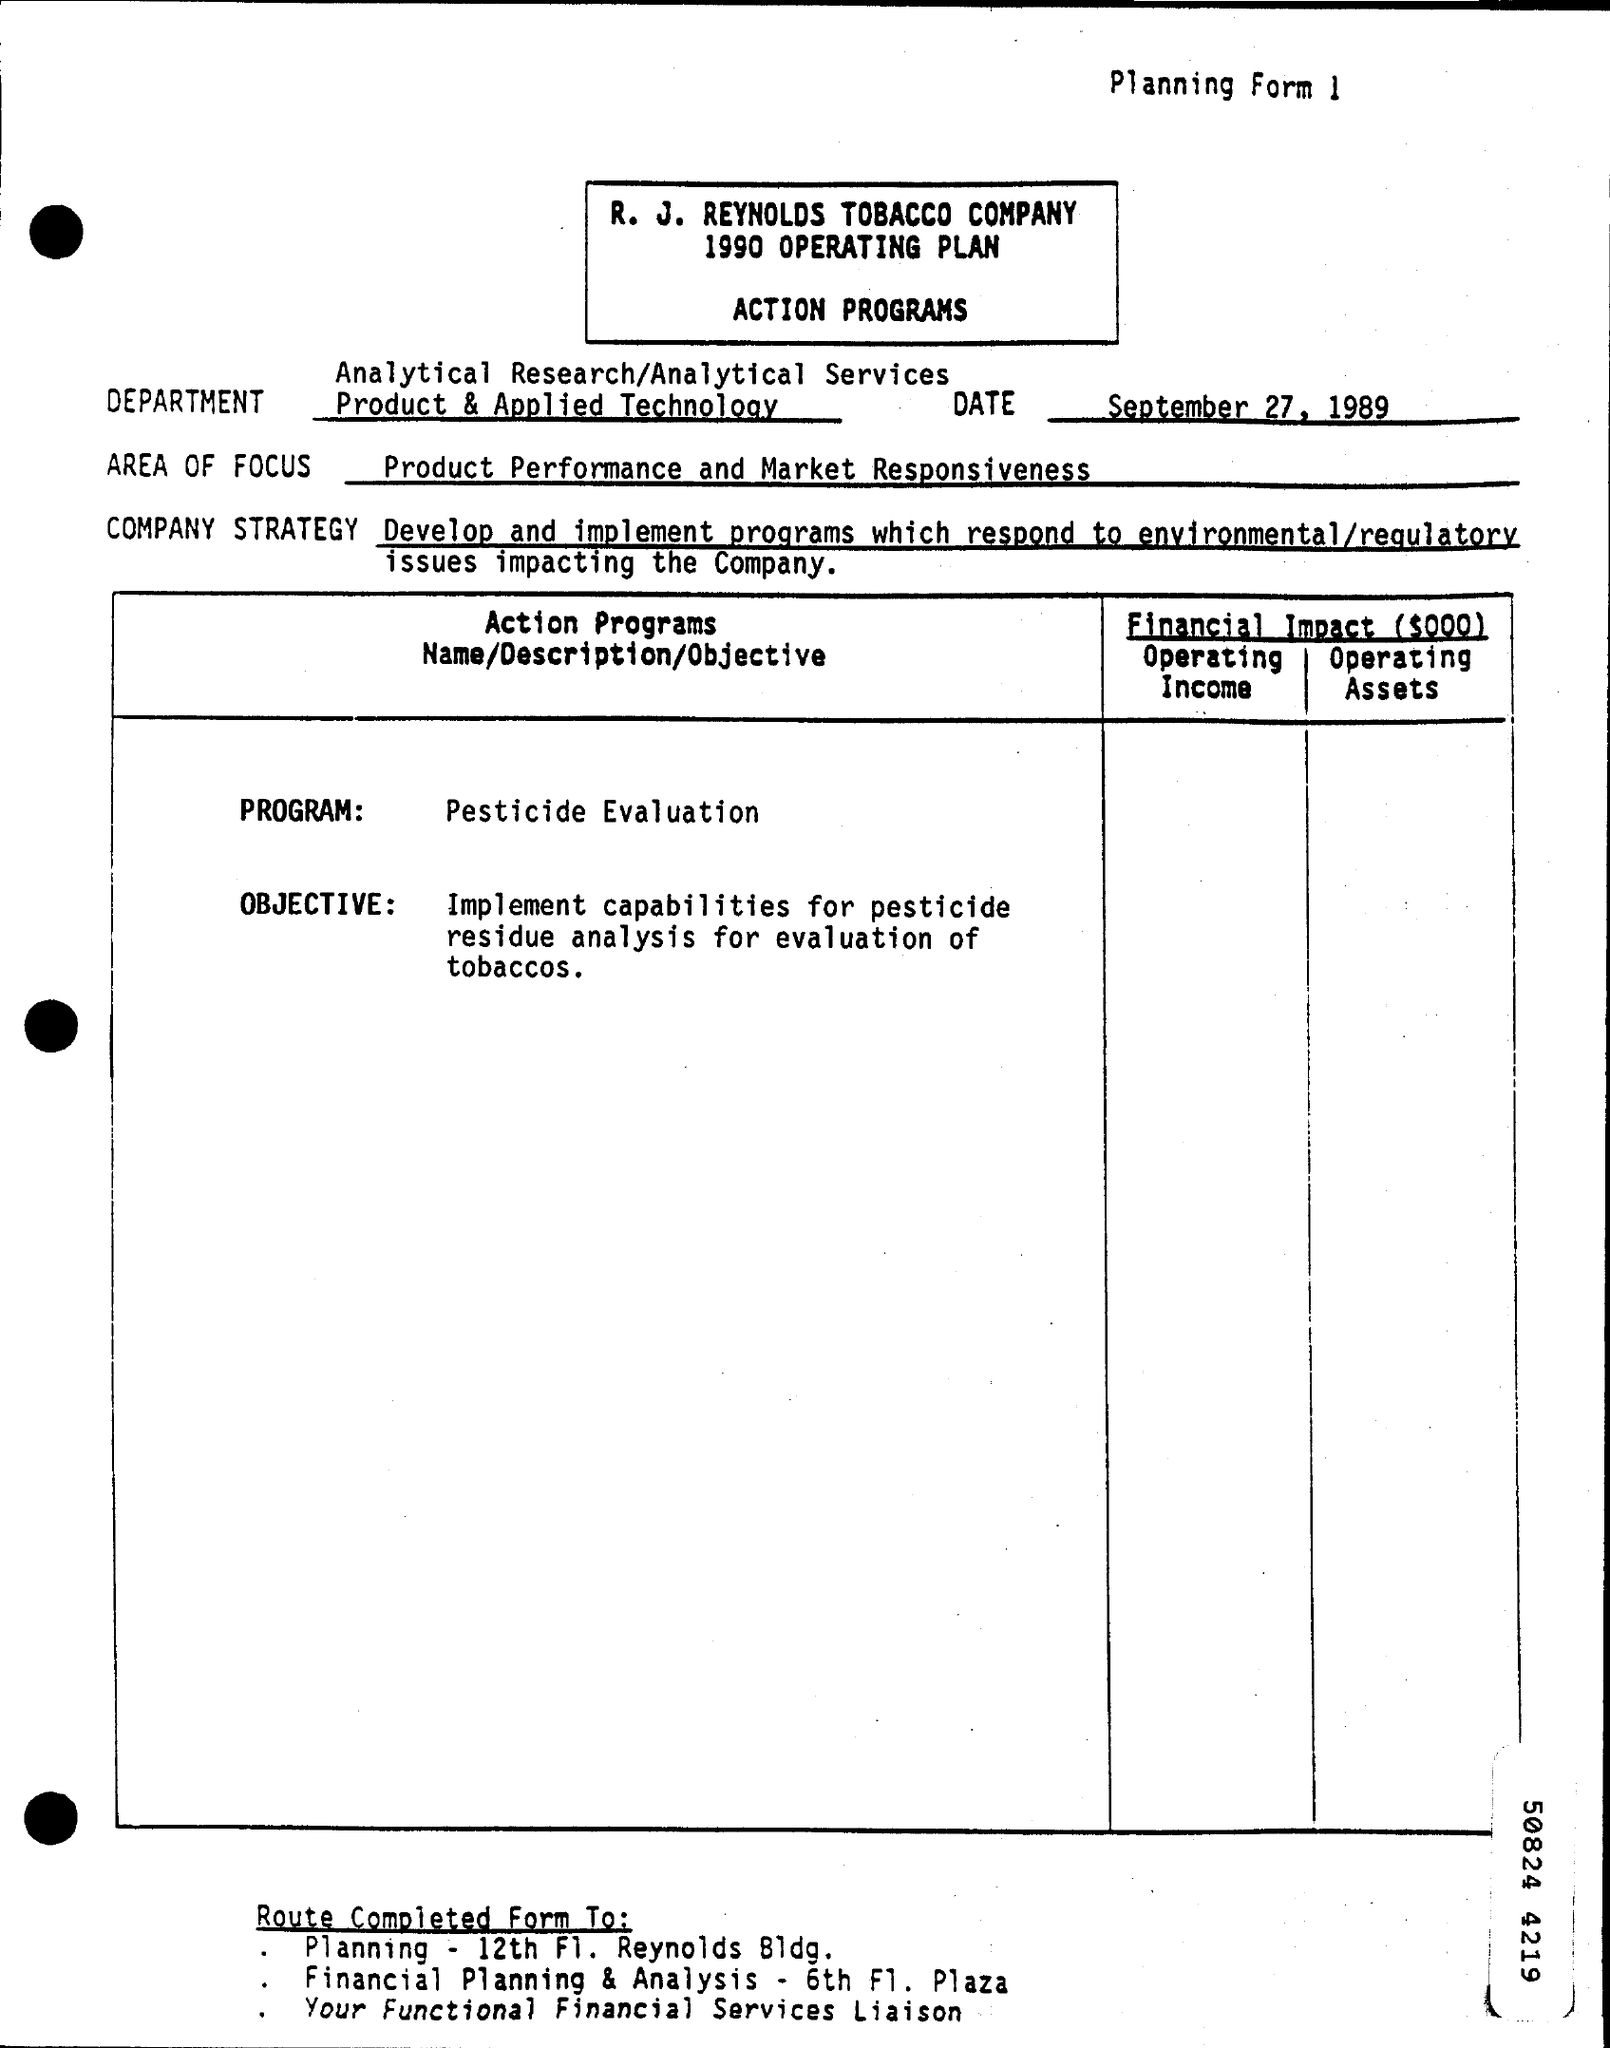Mention a couple of crucial points in this snapshot. The date of September 27, 1989, has been found. 